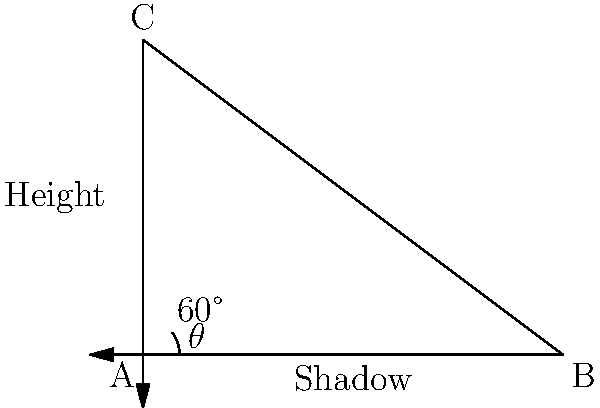As the head of the tech department, you're tasked with creating a visualization for a new skyscraper project. To accurately represent the building's height in your 3D model, you need to calculate it based on available data. Given that the skyscraper casts a shadow of 80 meters and the angle of elevation of the sun is 60°, what is the height of the skyscraper? To solve this problem, we'll use trigonometry, specifically the tangent function. Let's break it down step-by-step:

1) In a right triangle, tangent of an angle is the ratio of the opposite side to the adjacent side.

   $\tan \theta = \frac{\text{opposite}}{\text{adjacent}}$

2) In our case:
   - The angle $\theta$ is 60°
   - The adjacent side is the length of the shadow (80 meters)
   - The opposite side is the height of the skyscraper (what we're solving for)

3) Let's call the height of the skyscraper $h$. We can set up the equation:

   $\tan 60° = \frac{h}{80}$

4) We know that $\tan 60° = \sqrt{3}$, so we can rewrite the equation:

   $\sqrt{3} = \frac{h}{80}$

5) To solve for $h$, multiply both sides by 80:

   $h = 80\sqrt{3}$

6) Calculate the value:

   $h = 80 * 1.732050808 \approx 138.56$ meters

Therefore, the height of the skyscraper is approximately 138.56 meters.
Answer: $138.56$ meters 